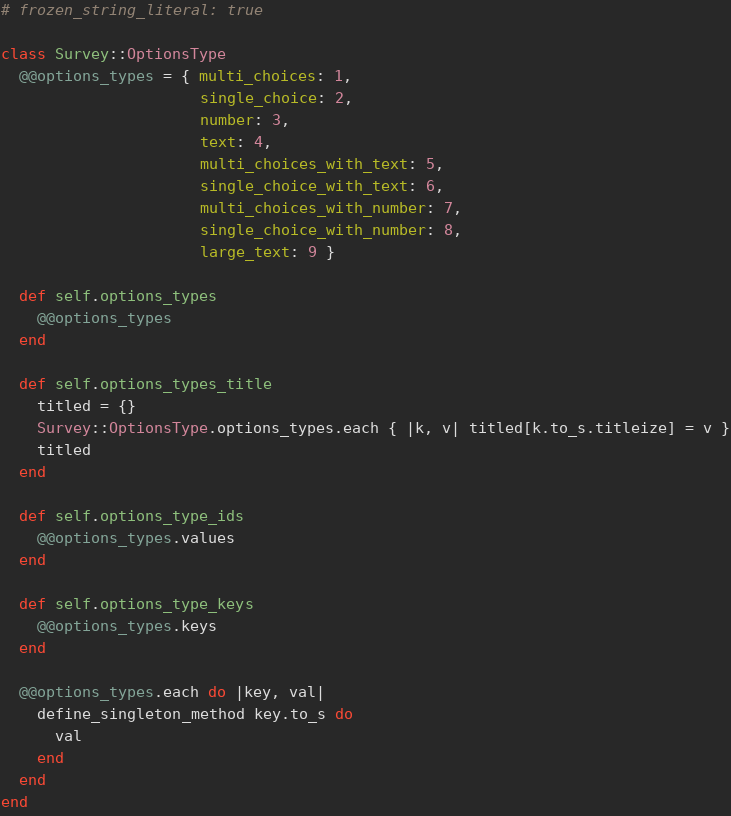<code> <loc_0><loc_0><loc_500><loc_500><_Ruby_># frozen_string_literal: true

class Survey::OptionsType
  @@options_types = { multi_choices: 1,
                      single_choice: 2,
                      number: 3,
                      text: 4,
                      multi_choices_with_text: 5,
                      single_choice_with_text: 6,
                      multi_choices_with_number: 7,
                      single_choice_with_number: 8,
                      large_text: 9 }

  def self.options_types
    @@options_types
  end

  def self.options_types_title
    titled = {}
    Survey::OptionsType.options_types.each { |k, v| titled[k.to_s.titleize] = v }
    titled
  end

  def self.options_type_ids
    @@options_types.values
  end

  def self.options_type_keys
    @@options_types.keys
  end

  @@options_types.each do |key, val|
    define_singleton_method key.to_s do
      val
    end
  end
end
</code> 